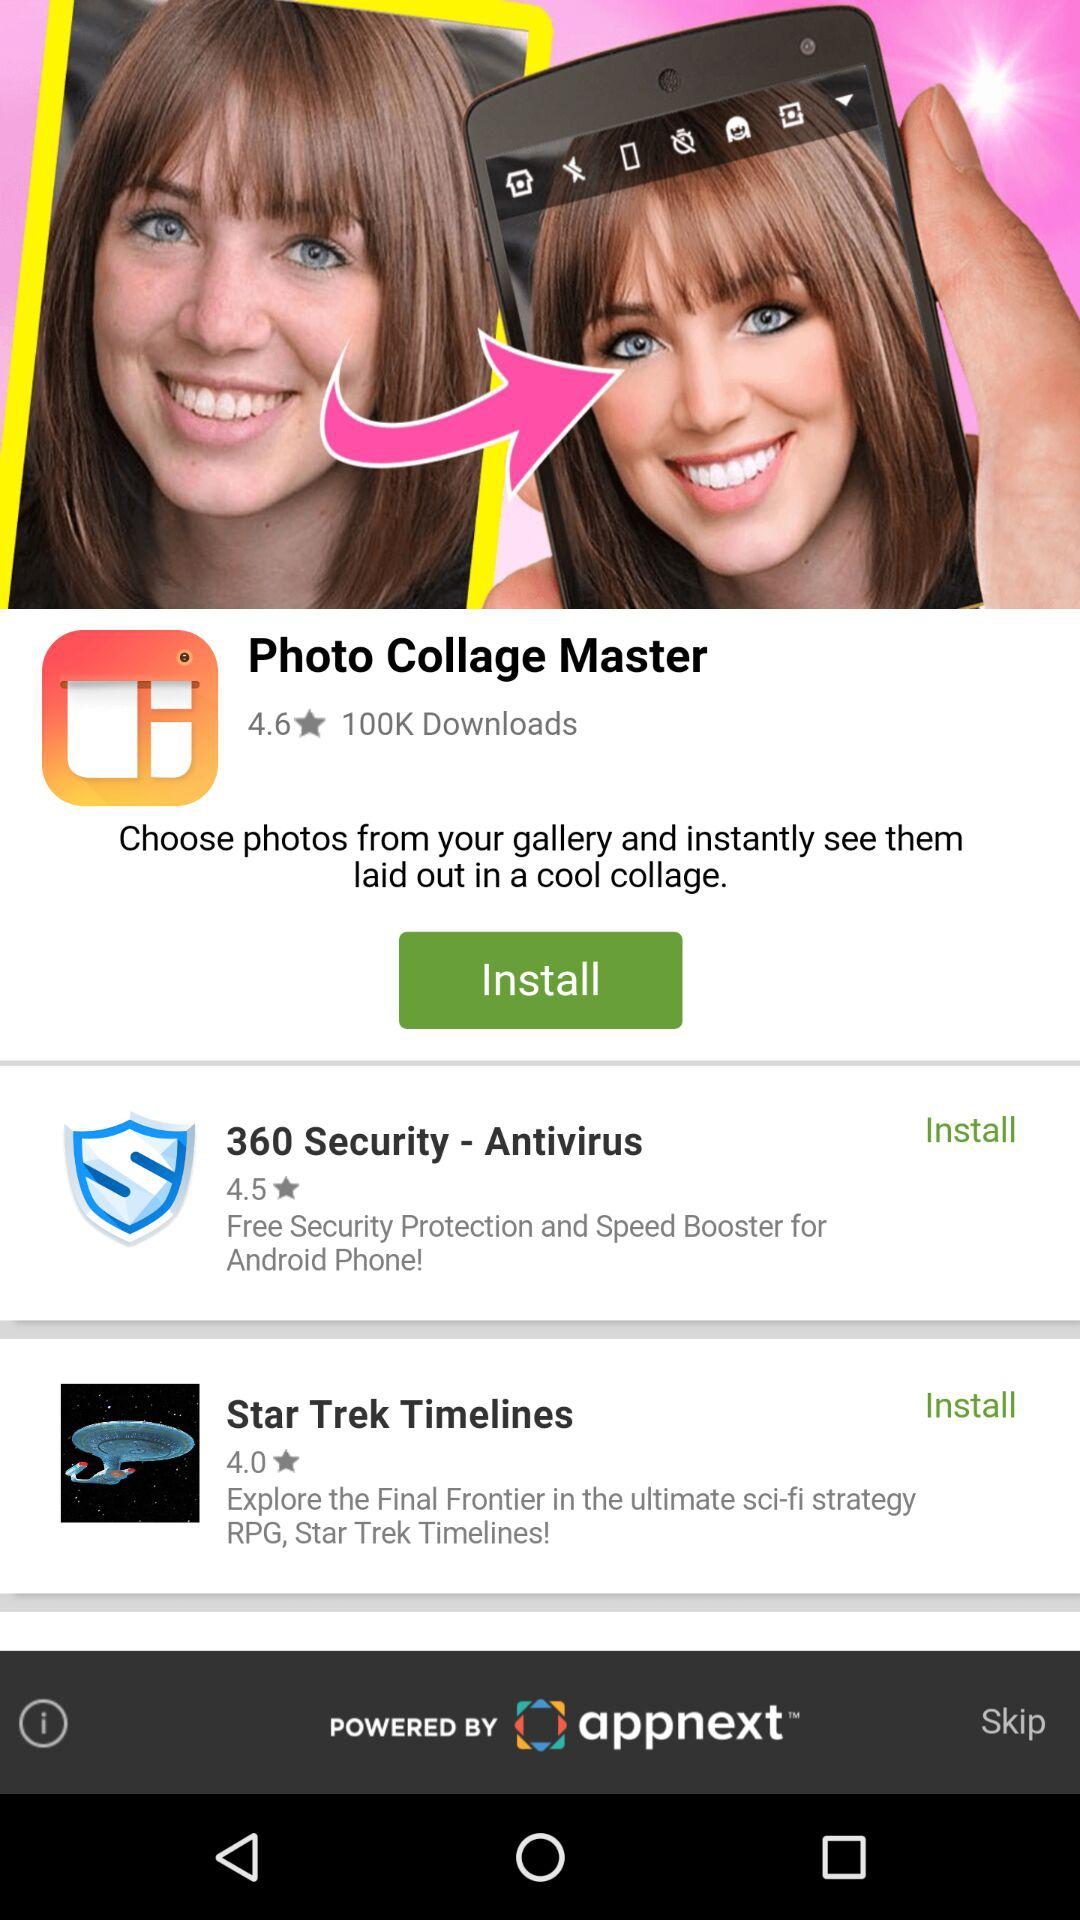By what all the apps are powered by? The apps are powered by "appnext™". 